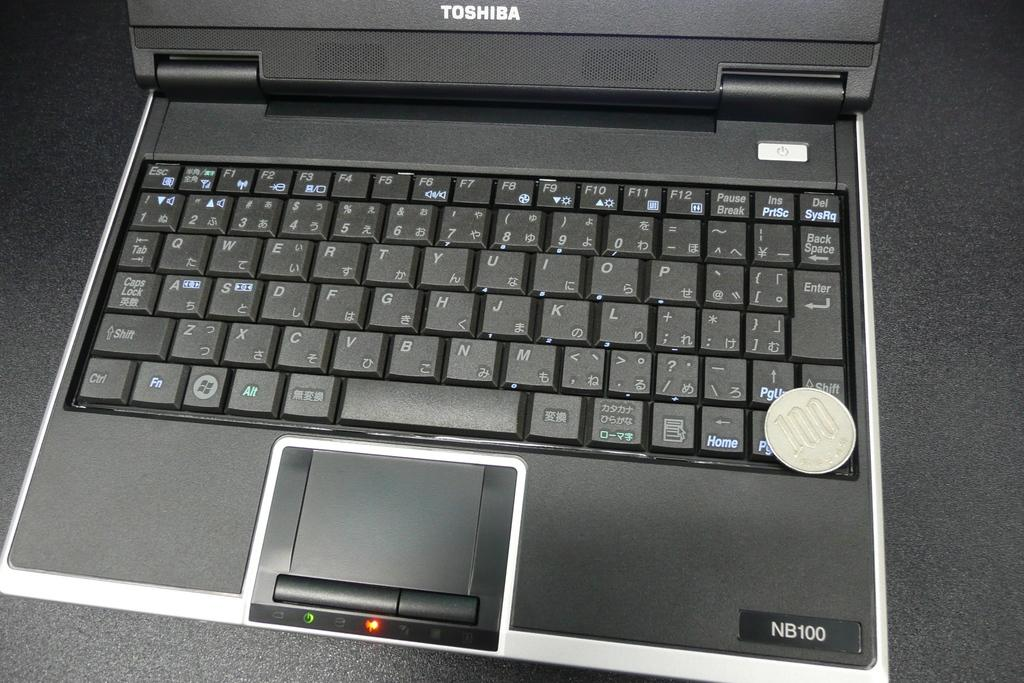<image>
Provide a brief description of the given image. A toshiba laptop, model NB100, with a touchpad. 